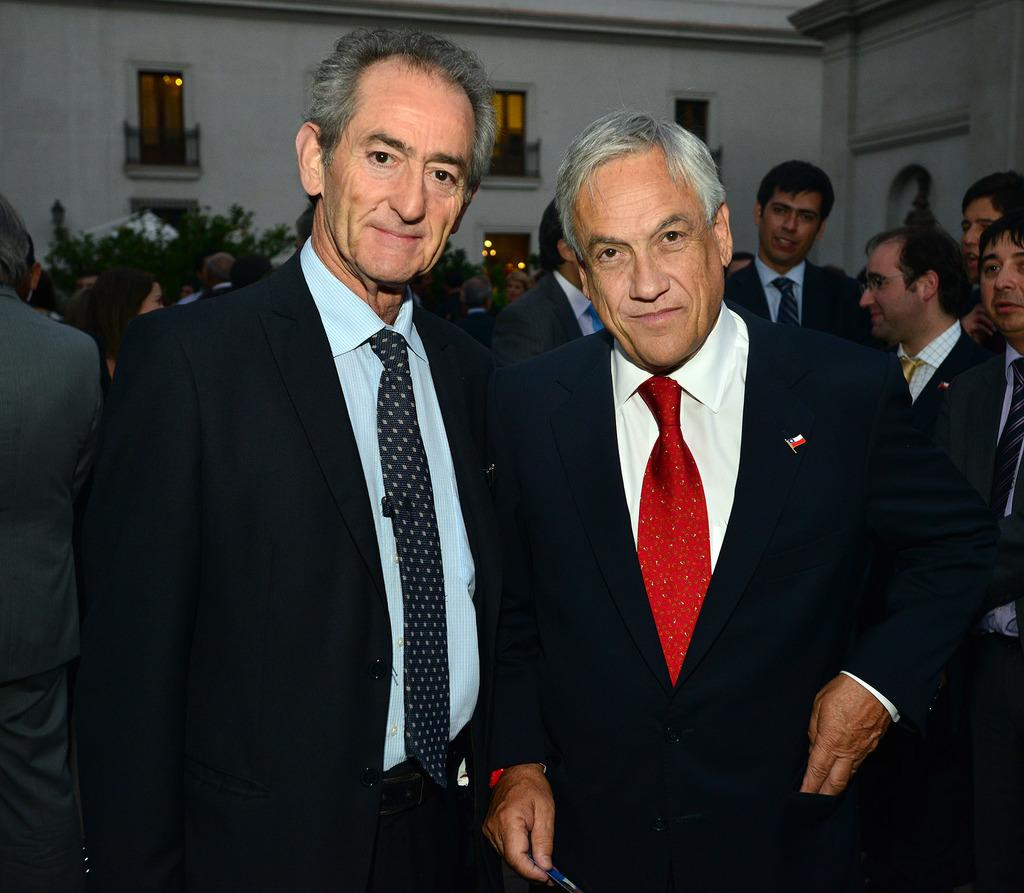How many people are in the image? There are persons in the image. Can you describe the arrangement of the persons in the image? There are two persons in the middle of the image. What can be seen in the background of the image? There is a building in the background of the image. What type of metal is the watch worn by the achiever in the image? There is no watch or achiever present in the image. 